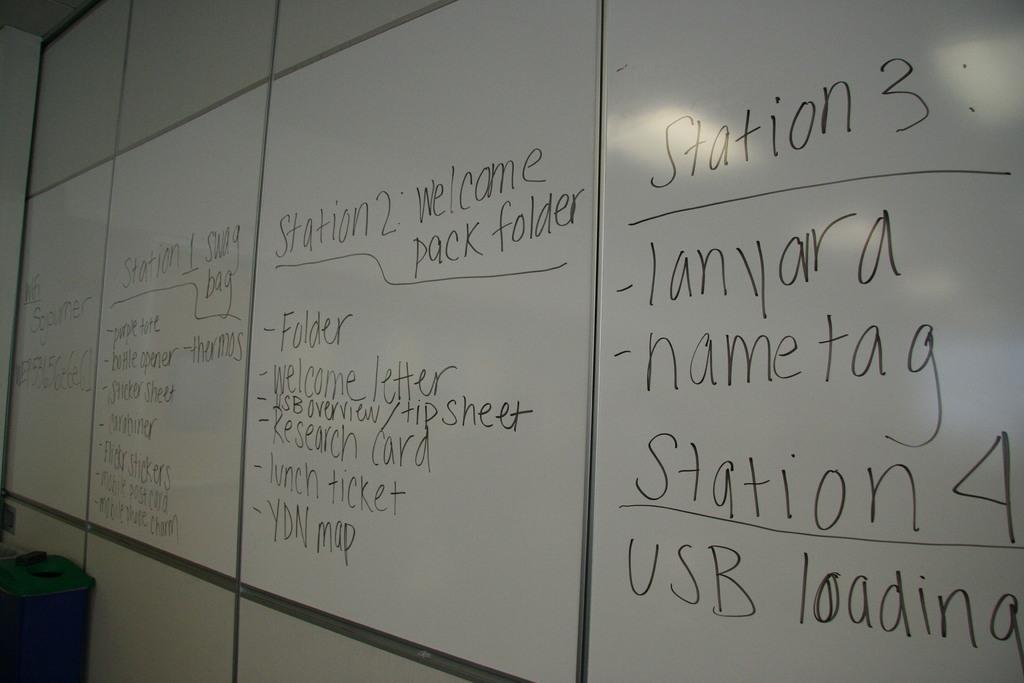<image>
Summarize the visual content of the image. White board for a college with stations detailing where to pick up welcome items. 